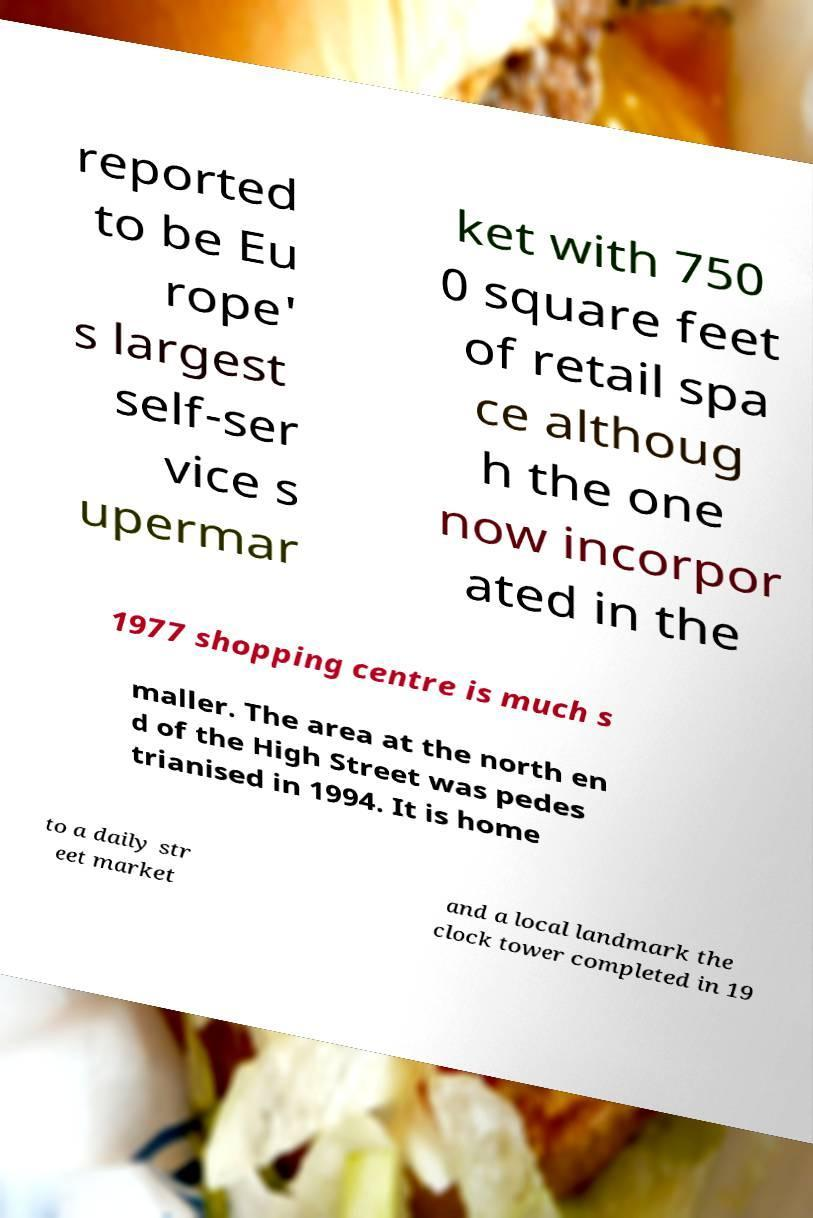There's text embedded in this image that I need extracted. Can you transcribe it verbatim? reported to be Eu rope' s largest self-ser vice s upermar ket with 750 0 square feet of retail spa ce althoug h the one now incorpor ated in the 1977 shopping centre is much s maller. The area at the north en d of the High Street was pedes trianised in 1994. It is home to a daily str eet market and a local landmark the clock tower completed in 19 